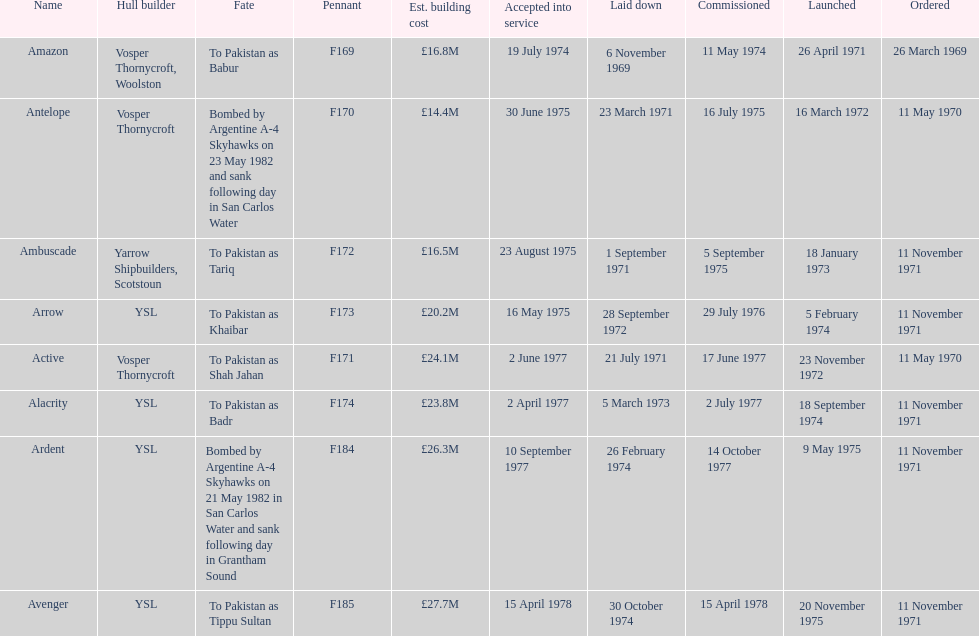What is the last name listed on this chart? Avenger. 